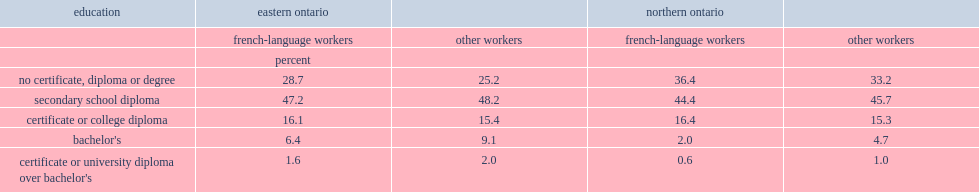In 2011, what percent of french-language workers in northern ontario did not have a certificate, diploma, or degree? 36.4. 